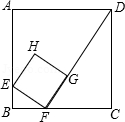First perform reasoning, then finally select the question from the choices in the following format: Answer: xxx.
Question: In the square ABCD with side length 6.0, there is a small square EFGH, where E, F, and G are on AB, BC, and FD respectively. If BF = 1.5, how long is the side of the small square?
Choices:
A: 1.0√{3}
B: 1.875
C: 2.5
D: 3.0 Since the side length of square ABCD is 6, we have BC = CD = 6. Given that BF = 1.5, CF can be calculated as CF = BC - BF = 6 - 1.5 = 4.5. In square EFGH, we know that angle EFG is 90°. Therefore, angle BFE + angle CFD = 90°. In right triangle BEF, we have angle BEF + angle BFE = 90°, which implies angle BEF = angle CFD. Additionally, since angle B = angle C = 90°, triangles BFE and CDF are similar. Thus, we have BE/CF = BF/CD, which is equivalent to BE/4.5 = 1.5/6. Solving for BE gives BE = 4.5/4. In right triangle BEF, we can use the Pythagorean theorem to find EF. EF = √(BE^2 + BF^2) = √((4.5/4)^2 + 1.5^2) = 15/8 = 1.875. Therefore, the answer is B.
Answer:B 